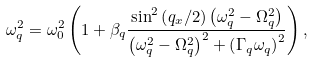Convert formula to latex. <formula><loc_0><loc_0><loc_500><loc_500>\omega _ { q } ^ { 2 } = \omega _ { 0 } ^ { 2 } \left ( 1 + \beta _ { q } \frac { \sin ^ { 2 } \left ( q _ { x } / 2 \right ) \left ( \omega _ { q } ^ { 2 } - \Omega _ { q } ^ { 2 } \right ) } { \left ( \omega _ { q } ^ { 2 } - \Omega _ { q } ^ { 2 } \right ) ^ { 2 } + \left ( \Gamma _ { q } \omega _ { q } \right ) ^ { 2 } } \right ) ,</formula> 